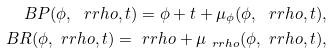<formula> <loc_0><loc_0><loc_500><loc_500>\ B P ( \phi , \ r r h o , t ) = \phi + t + \mu _ { \phi } ( \phi , \ r r h o , t ) , \\ \ B R ( \phi , \ r r h o , t ) = \ r r h o + \mu _ { \ r r h o } ( \phi , \ r r h o , t ) ,</formula> 